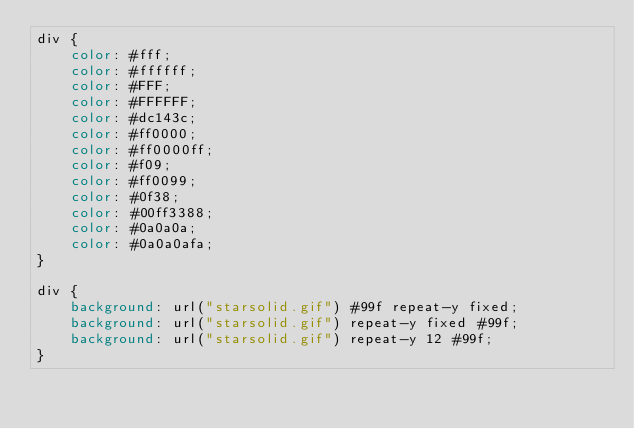Convert code to text. <code><loc_0><loc_0><loc_500><loc_500><_CSS_>div {
    color: #fff;
    color: #ffffff;
    color: #FFF;
    color: #FFFFFF;
    color: #dc143c;
    color: #ff0000;
    color: #ff0000ff;
    color: #f09;
    color: #ff0099;
    color: #0f38;
    color: #00ff3388;
    color: #0a0a0a;
    color: #0a0a0afa;
}

div {
    background: url("starsolid.gif") #99f repeat-y fixed;
    background: url("starsolid.gif") repeat-y fixed #99f;
    background: url("starsolid.gif") repeat-y 12 #99f;
}
</code> 